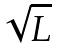<formula> <loc_0><loc_0><loc_500><loc_500>\sqrt { L }</formula> 